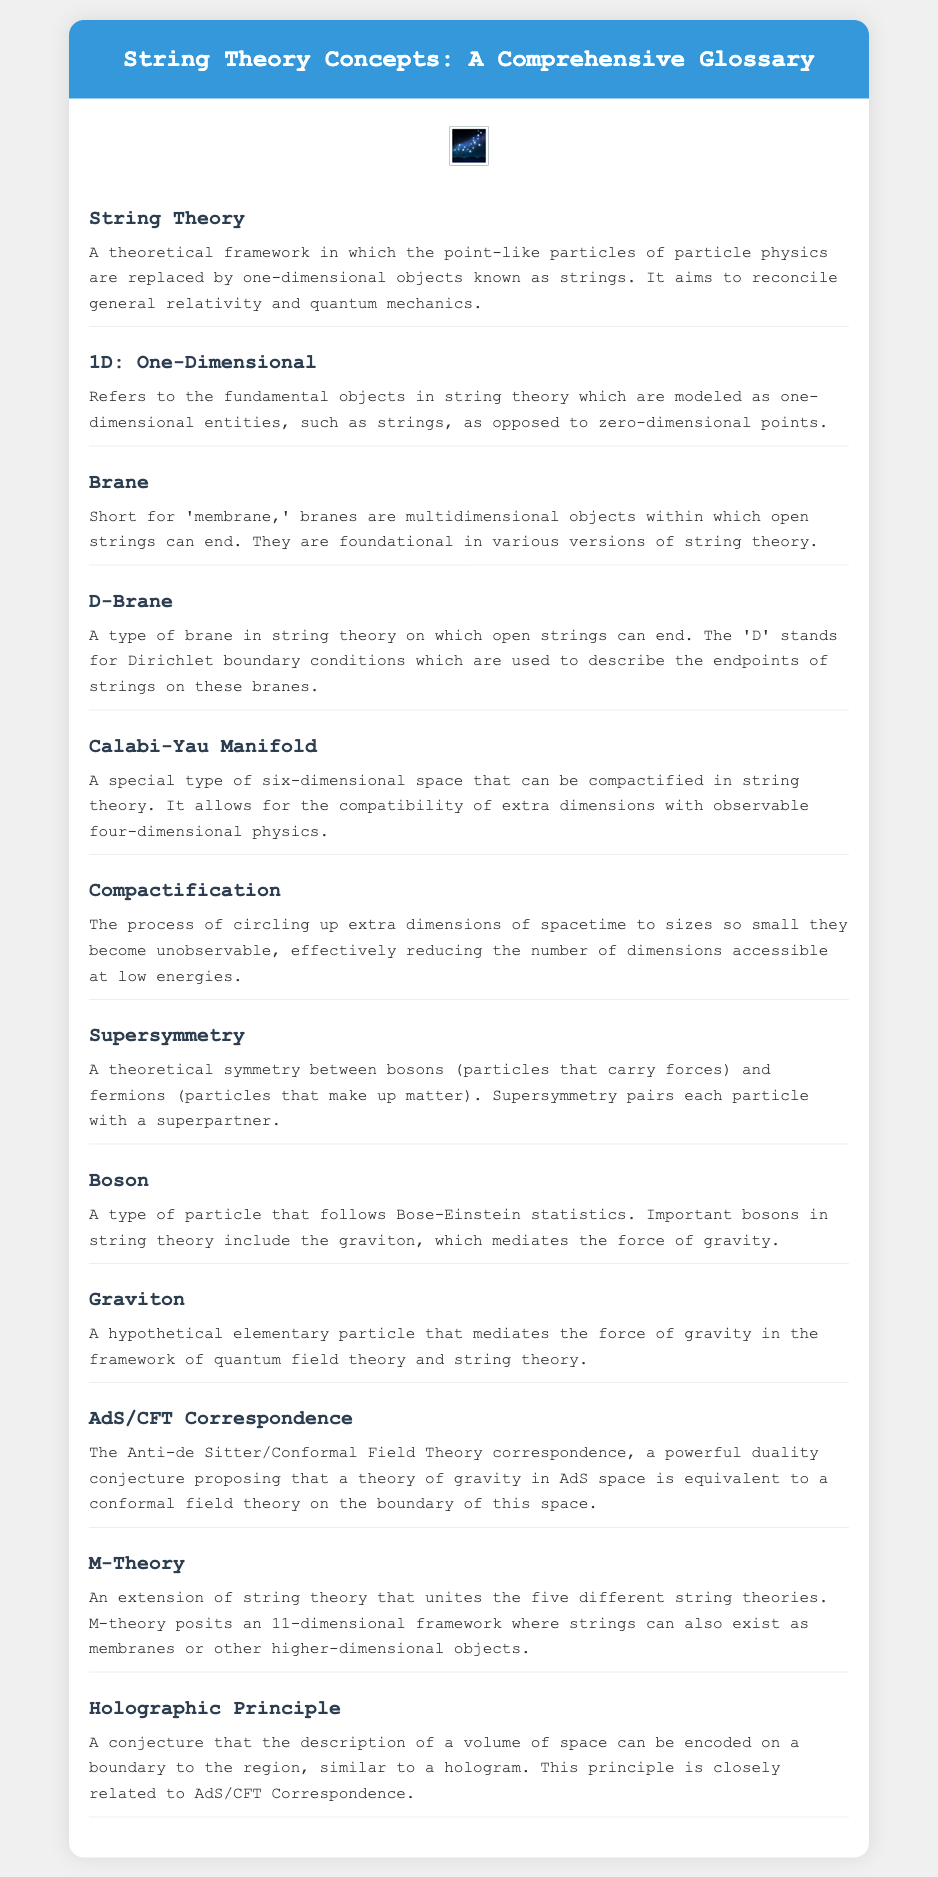What is the title of the document? The title is stated at the top of the document as "String Theory Concepts: A Comprehensive Glossary."
Answer: String Theory Concepts: A Comprehensive Glossary What does "D-Brane" stand for? The 'D' in D-Brane stands for Dirichlet boundary conditions used to describe the endpoints of strings on these branes.
Answer: Dirichlet How many dimensions does M-Theory propose? M-Theory posits an 11-dimensional framework.
Answer: 11 What type of manifold is associated with compactification in string theory? The document mentions that a Calabi-Yau Manifold is a special type of space used for compactification.
Answer: Calabi-Yau Manifold What type of particles do bosons pair with in supersymmetry? Supersymmetry pairs bosons with fermions.
Answer: Fermions What theoretical framework does string theory aim to reconcile? String theory aims to reconcile general relativity and quantum mechanics.
Answer: General relativity and quantum mechanics What principle is closely related to the AdS/CFT Correspondence? The Holographic Principle is closely related to the AdS/CFT Correspondence.
Answer: Holographic Principle What are the fundamental objects in string theory modeled as? The fundamental objects are modeled as one-dimensional entities, specifically strings.
Answer: Strings 